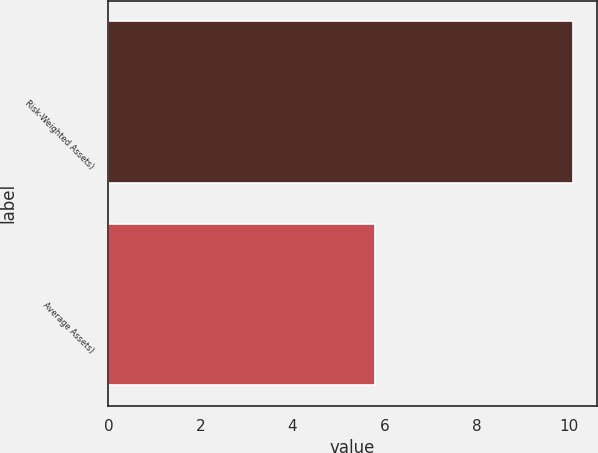<chart> <loc_0><loc_0><loc_500><loc_500><bar_chart><fcel>Risk-Weighted Assets)<fcel>Average Assets)<nl><fcel>10.1<fcel>5.8<nl></chart> 